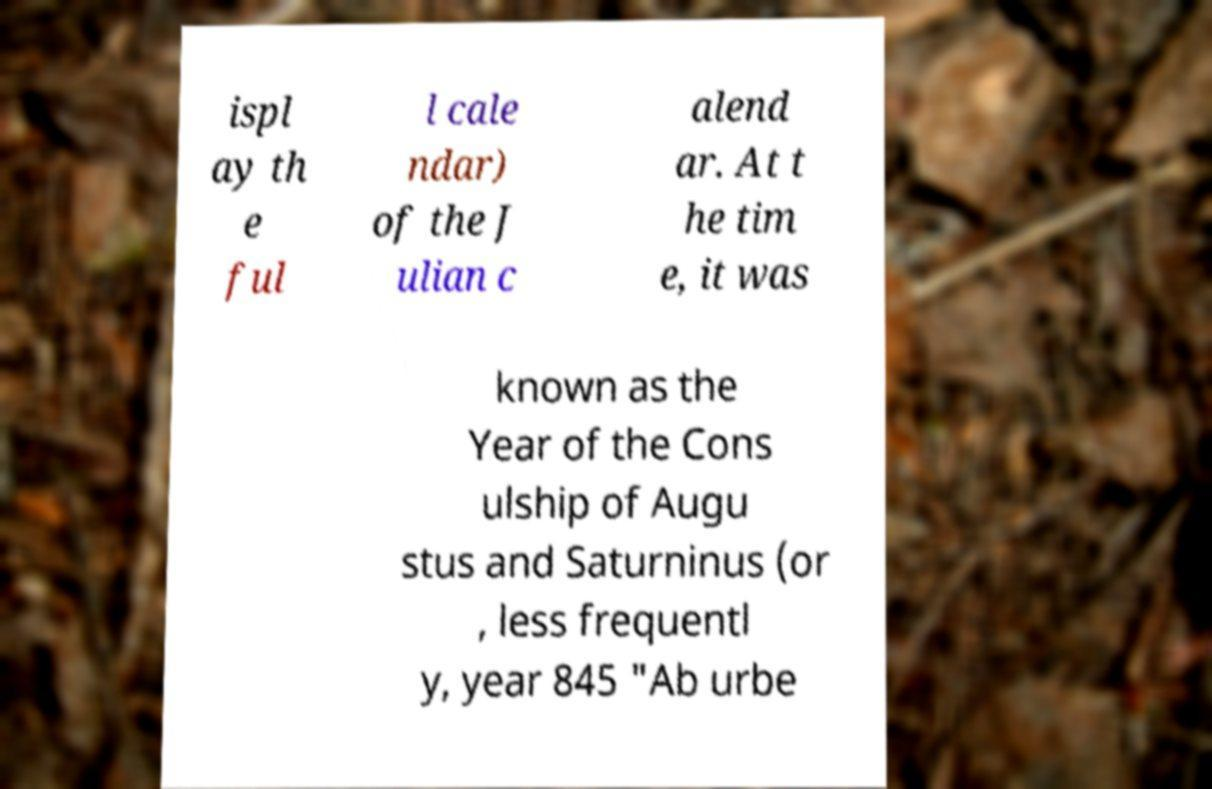There's text embedded in this image that I need extracted. Can you transcribe it verbatim? ispl ay th e ful l cale ndar) of the J ulian c alend ar. At t he tim e, it was known as the Year of the Cons ulship of Augu stus and Saturninus (or , less frequentl y, year 845 "Ab urbe 